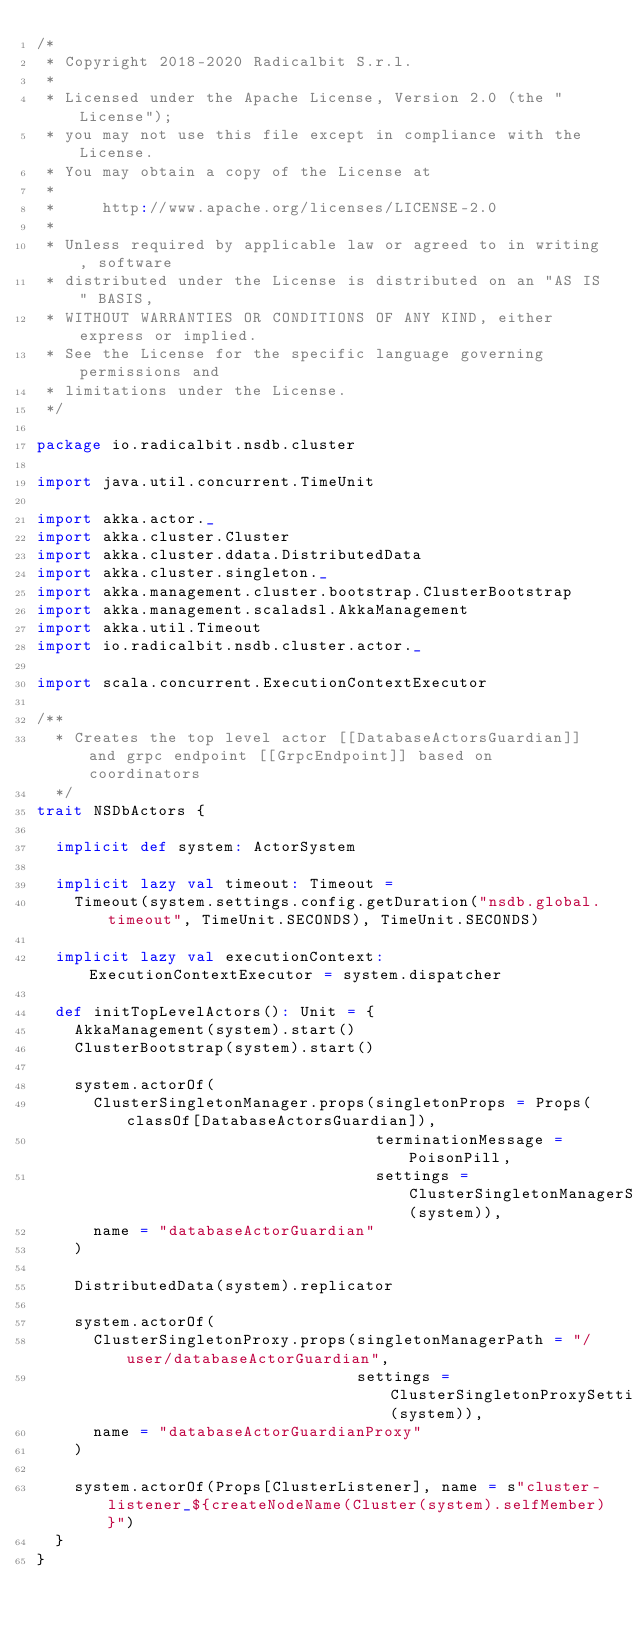Convert code to text. <code><loc_0><loc_0><loc_500><loc_500><_Scala_>/*
 * Copyright 2018-2020 Radicalbit S.r.l.
 *
 * Licensed under the Apache License, Version 2.0 (the "License");
 * you may not use this file except in compliance with the License.
 * You may obtain a copy of the License at
 *
 *     http://www.apache.org/licenses/LICENSE-2.0
 *
 * Unless required by applicable law or agreed to in writing, software
 * distributed under the License is distributed on an "AS IS" BASIS,
 * WITHOUT WARRANTIES OR CONDITIONS OF ANY KIND, either express or implied.
 * See the License for the specific language governing permissions and
 * limitations under the License.
 */

package io.radicalbit.nsdb.cluster

import java.util.concurrent.TimeUnit

import akka.actor._
import akka.cluster.Cluster
import akka.cluster.ddata.DistributedData
import akka.cluster.singleton._
import akka.management.cluster.bootstrap.ClusterBootstrap
import akka.management.scaladsl.AkkaManagement
import akka.util.Timeout
import io.radicalbit.nsdb.cluster.actor._

import scala.concurrent.ExecutionContextExecutor

/**
  * Creates the top level actor [[DatabaseActorsGuardian]] and grpc endpoint [[GrpcEndpoint]] based on coordinators
  */
trait NSDbActors {

  implicit def system: ActorSystem

  implicit lazy val timeout: Timeout =
    Timeout(system.settings.config.getDuration("nsdb.global.timeout", TimeUnit.SECONDS), TimeUnit.SECONDS)

  implicit lazy val executionContext: ExecutionContextExecutor = system.dispatcher

  def initTopLevelActors(): Unit = {
    AkkaManagement(system).start()
    ClusterBootstrap(system).start()

    system.actorOf(
      ClusterSingletonManager.props(singletonProps = Props(classOf[DatabaseActorsGuardian]),
                                    terminationMessage = PoisonPill,
                                    settings = ClusterSingletonManagerSettings(system)),
      name = "databaseActorGuardian"
    )

    DistributedData(system).replicator

    system.actorOf(
      ClusterSingletonProxy.props(singletonManagerPath = "/user/databaseActorGuardian",
                                  settings = ClusterSingletonProxySettings(system)),
      name = "databaseActorGuardianProxy"
    )

    system.actorOf(Props[ClusterListener], name = s"cluster-listener_${createNodeName(Cluster(system).selfMember)}")
  }
}
</code> 